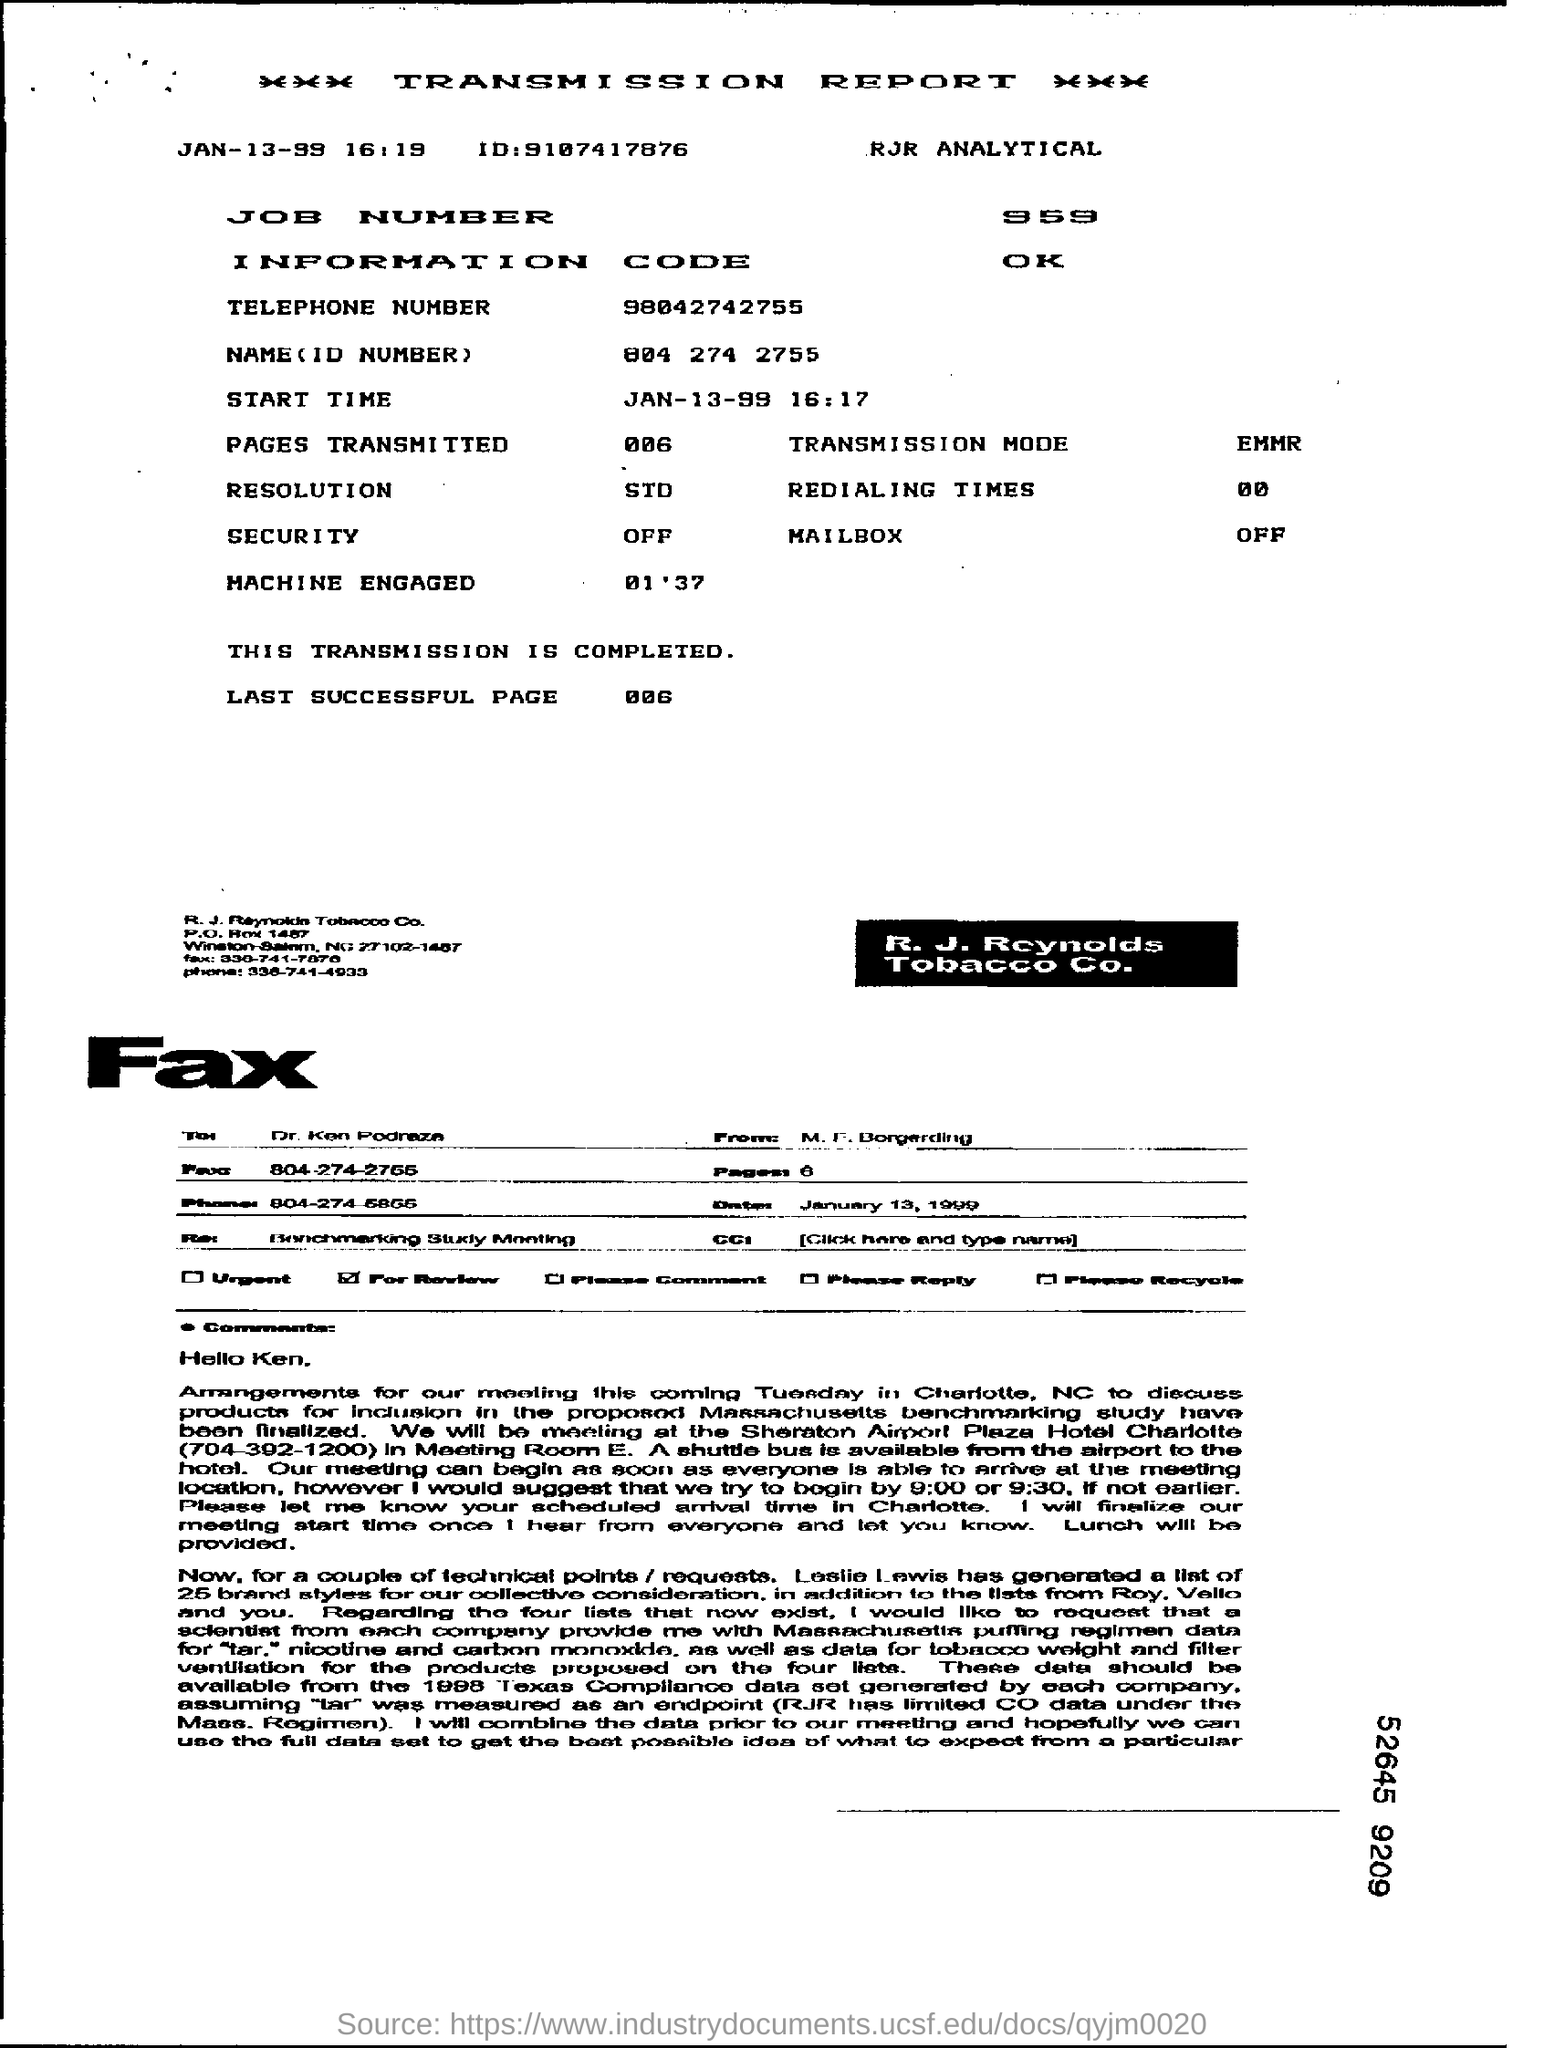Outline some significant characteristics in this image. The job number is 969. The number of pages transmitted is zero. The transmission starting time is 16:17. The report states that the transmission has been completed. 